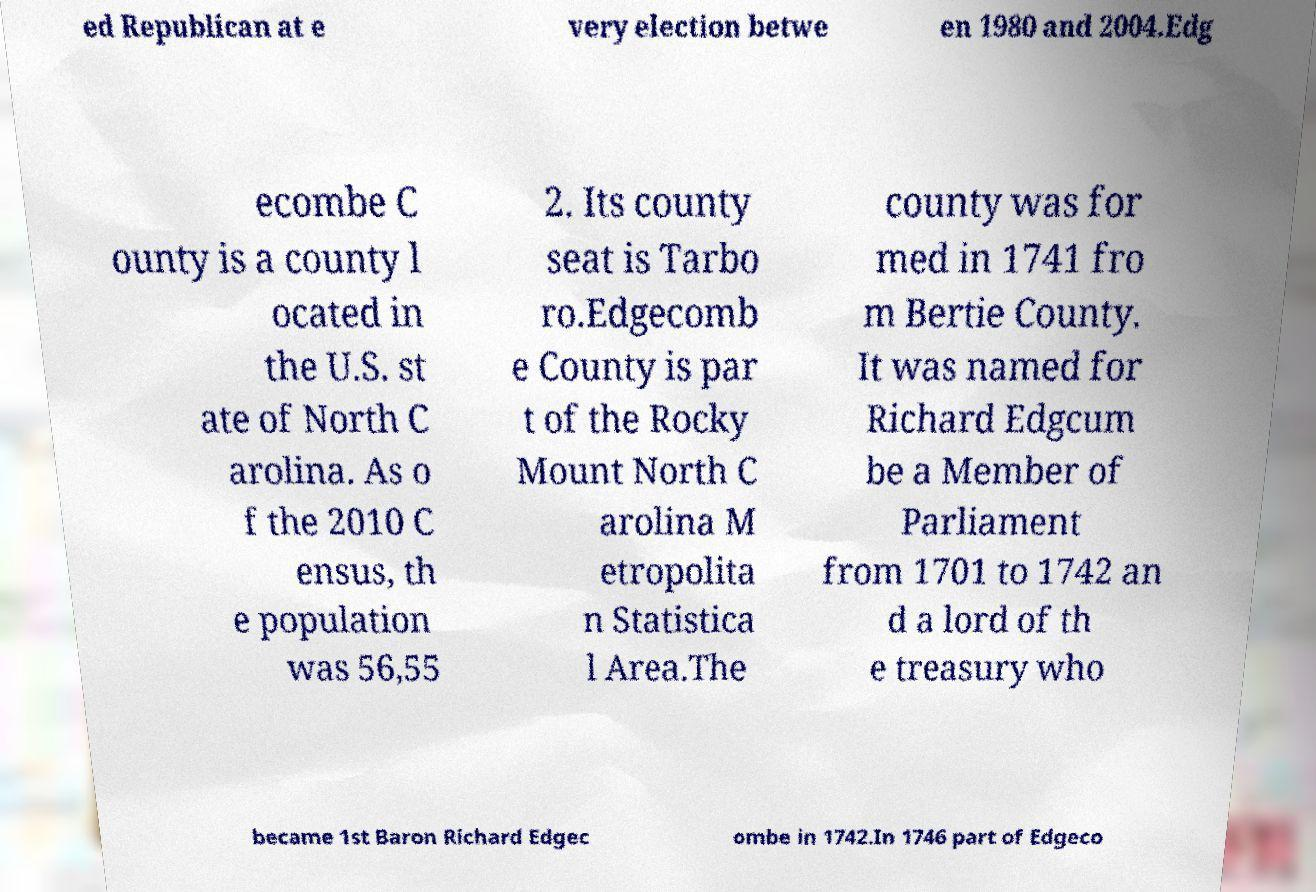Could you extract and type out the text from this image? ed Republican at e very election betwe en 1980 and 2004.Edg ecombe C ounty is a county l ocated in the U.S. st ate of North C arolina. As o f the 2010 C ensus, th e population was 56,55 2. Its county seat is Tarbo ro.Edgecomb e County is par t of the Rocky Mount North C arolina M etropolita n Statistica l Area.The county was for med in 1741 fro m Bertie County. It was named for Richard Edgcum be a Member of Parliament from 1701 to 1742 an d a lord of th e treasury who became 1st Baron Richard Edgec ombe in 1742.In 1746 part of Edgeco 